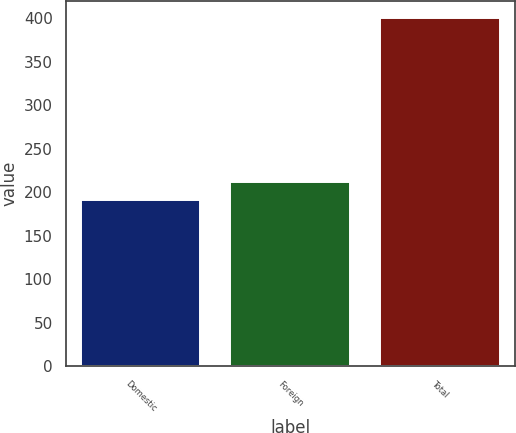Convert chart to OTSL. <chart><loc_0><loc_0><loc_500><loc_500><bar_chart><fcel>Domestic<fcel>Foreign<fcel>Total<nl><fcel>191.2<fcel>212.09<fcel>400.1<nl></chart> 